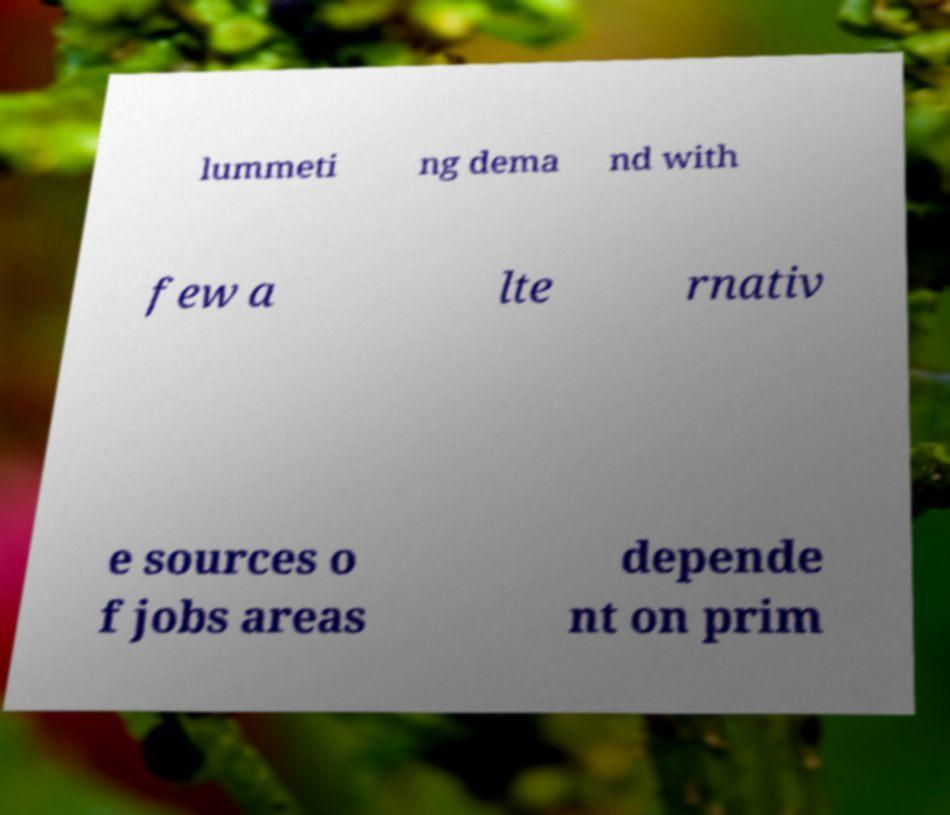For documentation purposes, I need the text within this image transcribed. Could you provide that? lummeti ng dema nd with few a lte rnativ e sources o f jobs areas depende nt on prim 